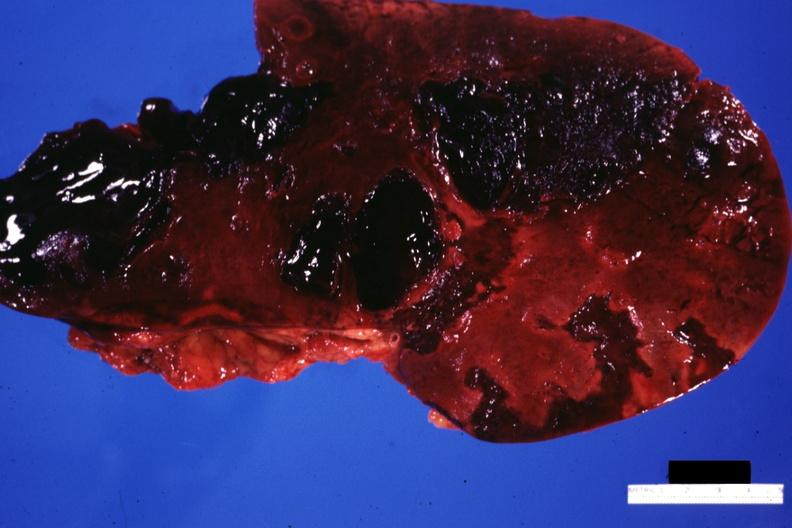s liver present?
Answer the question using a single word or phrase. Yes 